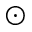Convert formula to latex. <formula><loc_0><loc_0><loc_500><loc_500>\odot</formula> 